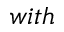Convert formula to latex. <formula><loc_0><loc_0><loc_500><loc_500>w i t h</formula> 